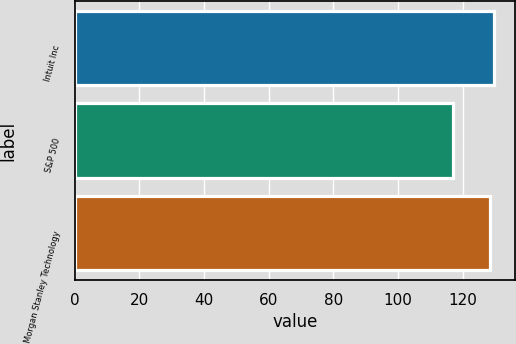Convert chart. <chart><loc_0><loc_0><loc_500><loc_500><bar_chart><fcel>Intuit Inc<fcel>S&P 500<fcel>Morgan Stanley Technology<nl><fcel>129.68<fcel>116.94<fcel>128.42<nl></chart> 